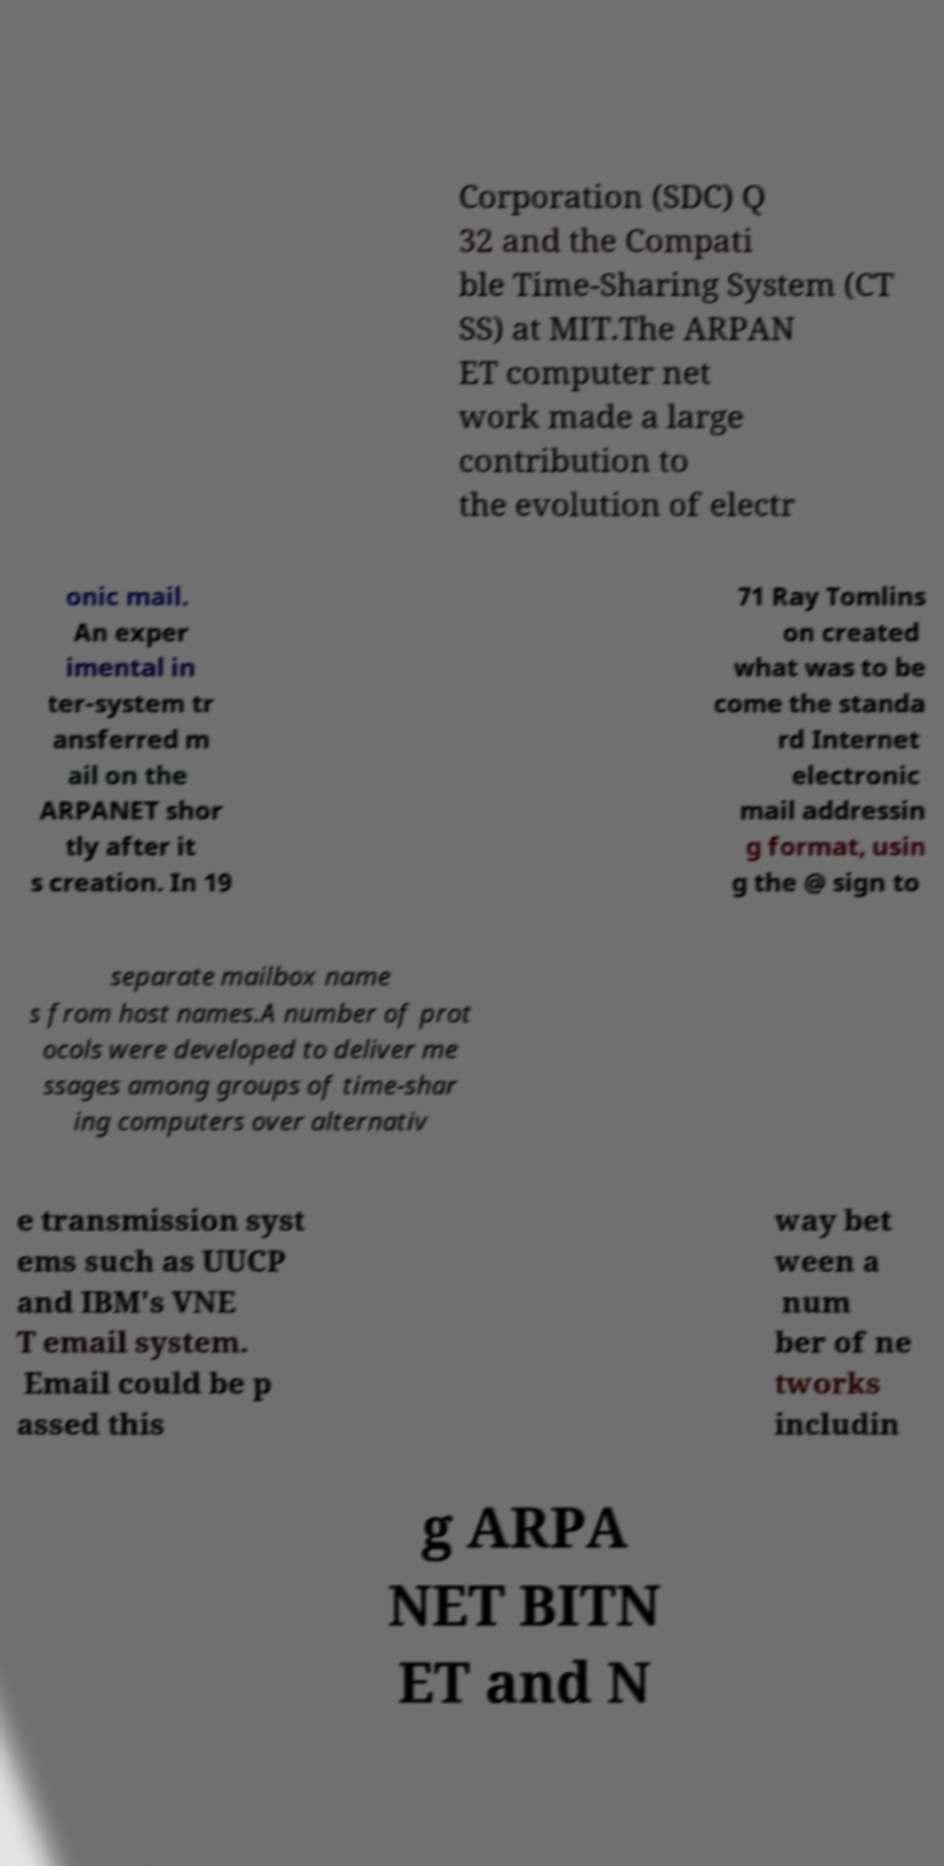There's text embedded in this image that I need extracted. Can you transcribe it verbatim? Corporation (SDC) Q 32 and the Compati ble Time-Sharing System (CT SS) at MIT.The ARPAN ET computer net work made a large contribution to the evolution of electr onic mail. An exper imental in ter-system tr ansferred m ail on the ARPANET shor tly after it s creation. In 19 71 Ray Tomlins on created what was to be come the standa rd Internet electronic mail addressin g format, usin g the @ sign to separate mailbox name s from host names.A number of prot ocols were developed to deliver me ssages among groups of time-shar ing computers over alternativ e transmission syst ems such as UUCP and IBM's VNE T email system. Email could be p assed this way bet ween a num ber of ne tworks includin g ARPA NET BITN ET and N 